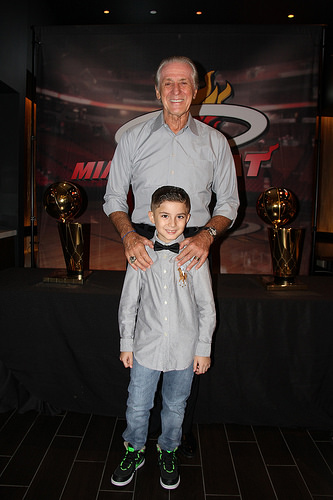<image>
Can you confirm if the person is behind the boy? Yes. From this viewpoint, the person is positioned behind the boy, with the boy partially or fully occluding the person. 